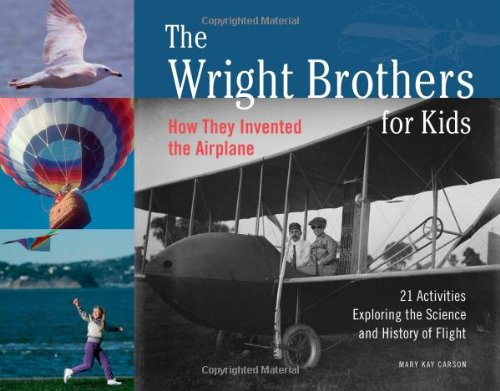How does this book make historical events engaging for kids? The book uses a combination of storytelling, vivid illustrations, and hands-on activities to bring the history of the Wright Brothers and their inventions to life, making the historical events both entertaining and educational for young readers. 